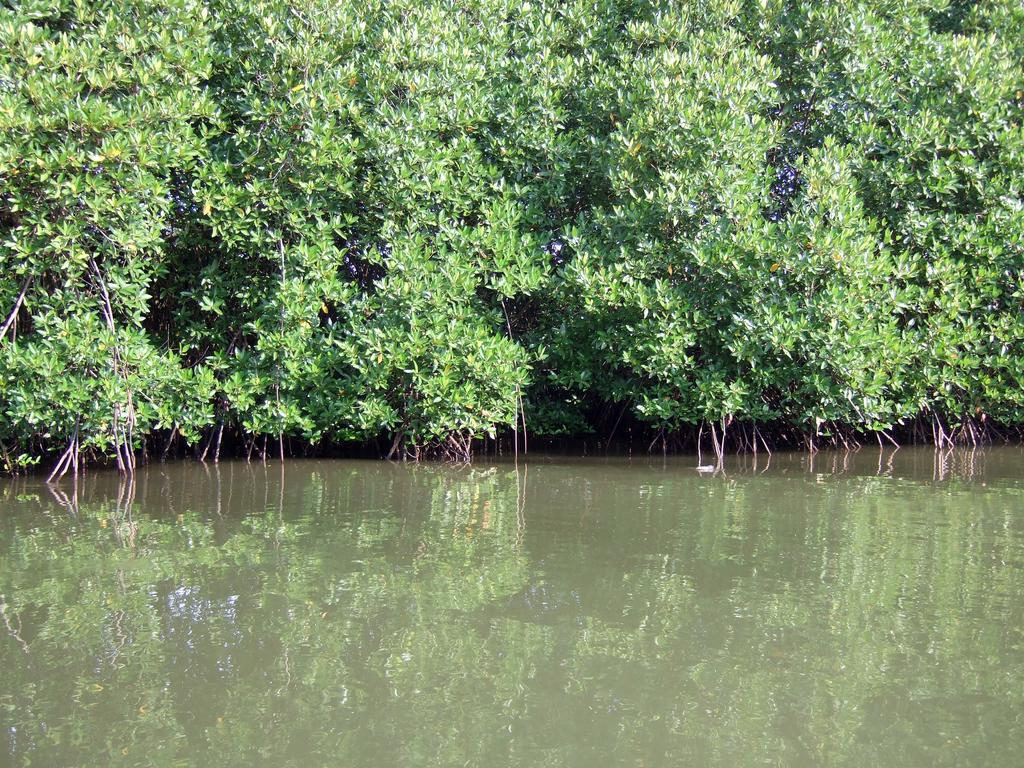What is located in the center of the image? There are trees in the center of the image. What else can be seen in the image besides the trees? There is water in the image. What effect does the water have on the appearance of the trees? The reflection of the trees is visible on the water. How many plastic items can be seen floating in the water in the image? There is no mention of plastic items in the image, so it cannot be determined how many might be floating in the water. 